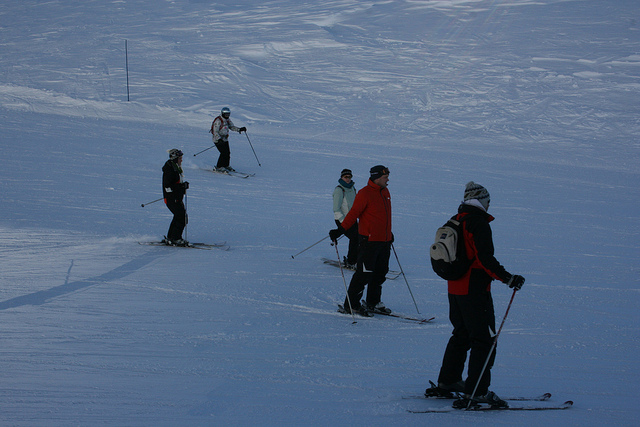<image>Where is a white helmet? The white helmet is not seen in the picture. It might be in the background. Where is a white helmet? I don't know where the white helmet is. It seems to be missing or not in the image. 